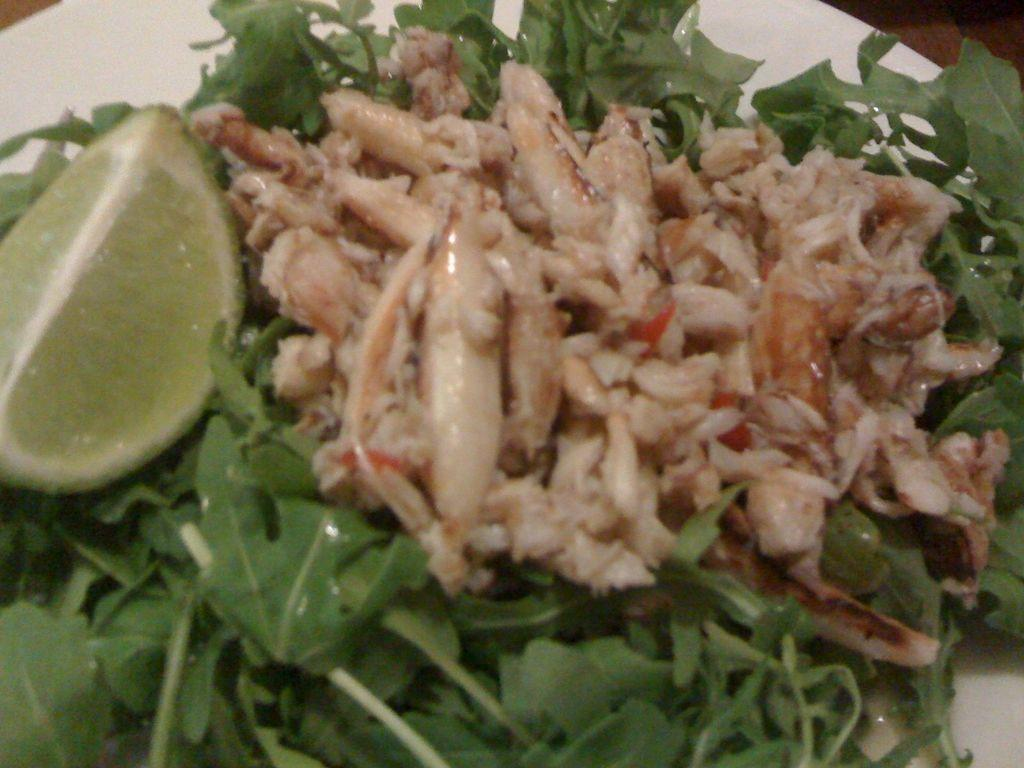What is on the plate that is visible in the image? There is a plate with food in the image. What color is the plate? The plate is white. What colors can be seen in the food on the plate? The food has green and light brown colors. What is the plate resting on in the image? The plate is on a brown surface. What type of crayon is being used to draw on the plate in the image? There is no crayon present in the image, and the plate is not being used for drawing. 